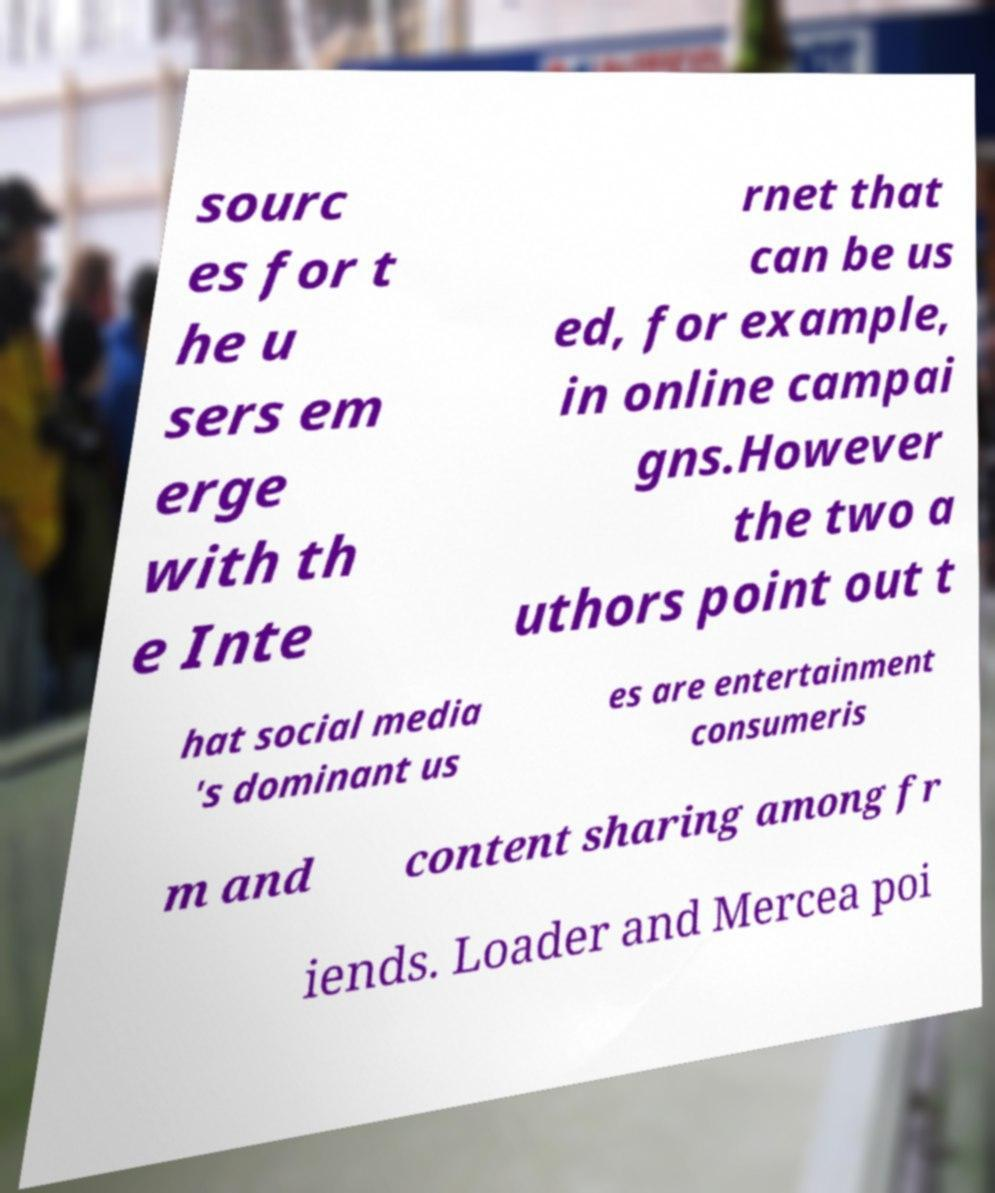Can you read and provide the text displayed in the image?This photo seems to have some interesting text. Can you extract and type it out for me? sourc es for t he u sers em erge with th e Inte rnet that can be us ed, for example, in online campai gns.However the two a uthors point out t hat social media 's dominant us es are entertainment consumeris m and content sharing among fr iends. Loader and Mercea poi 